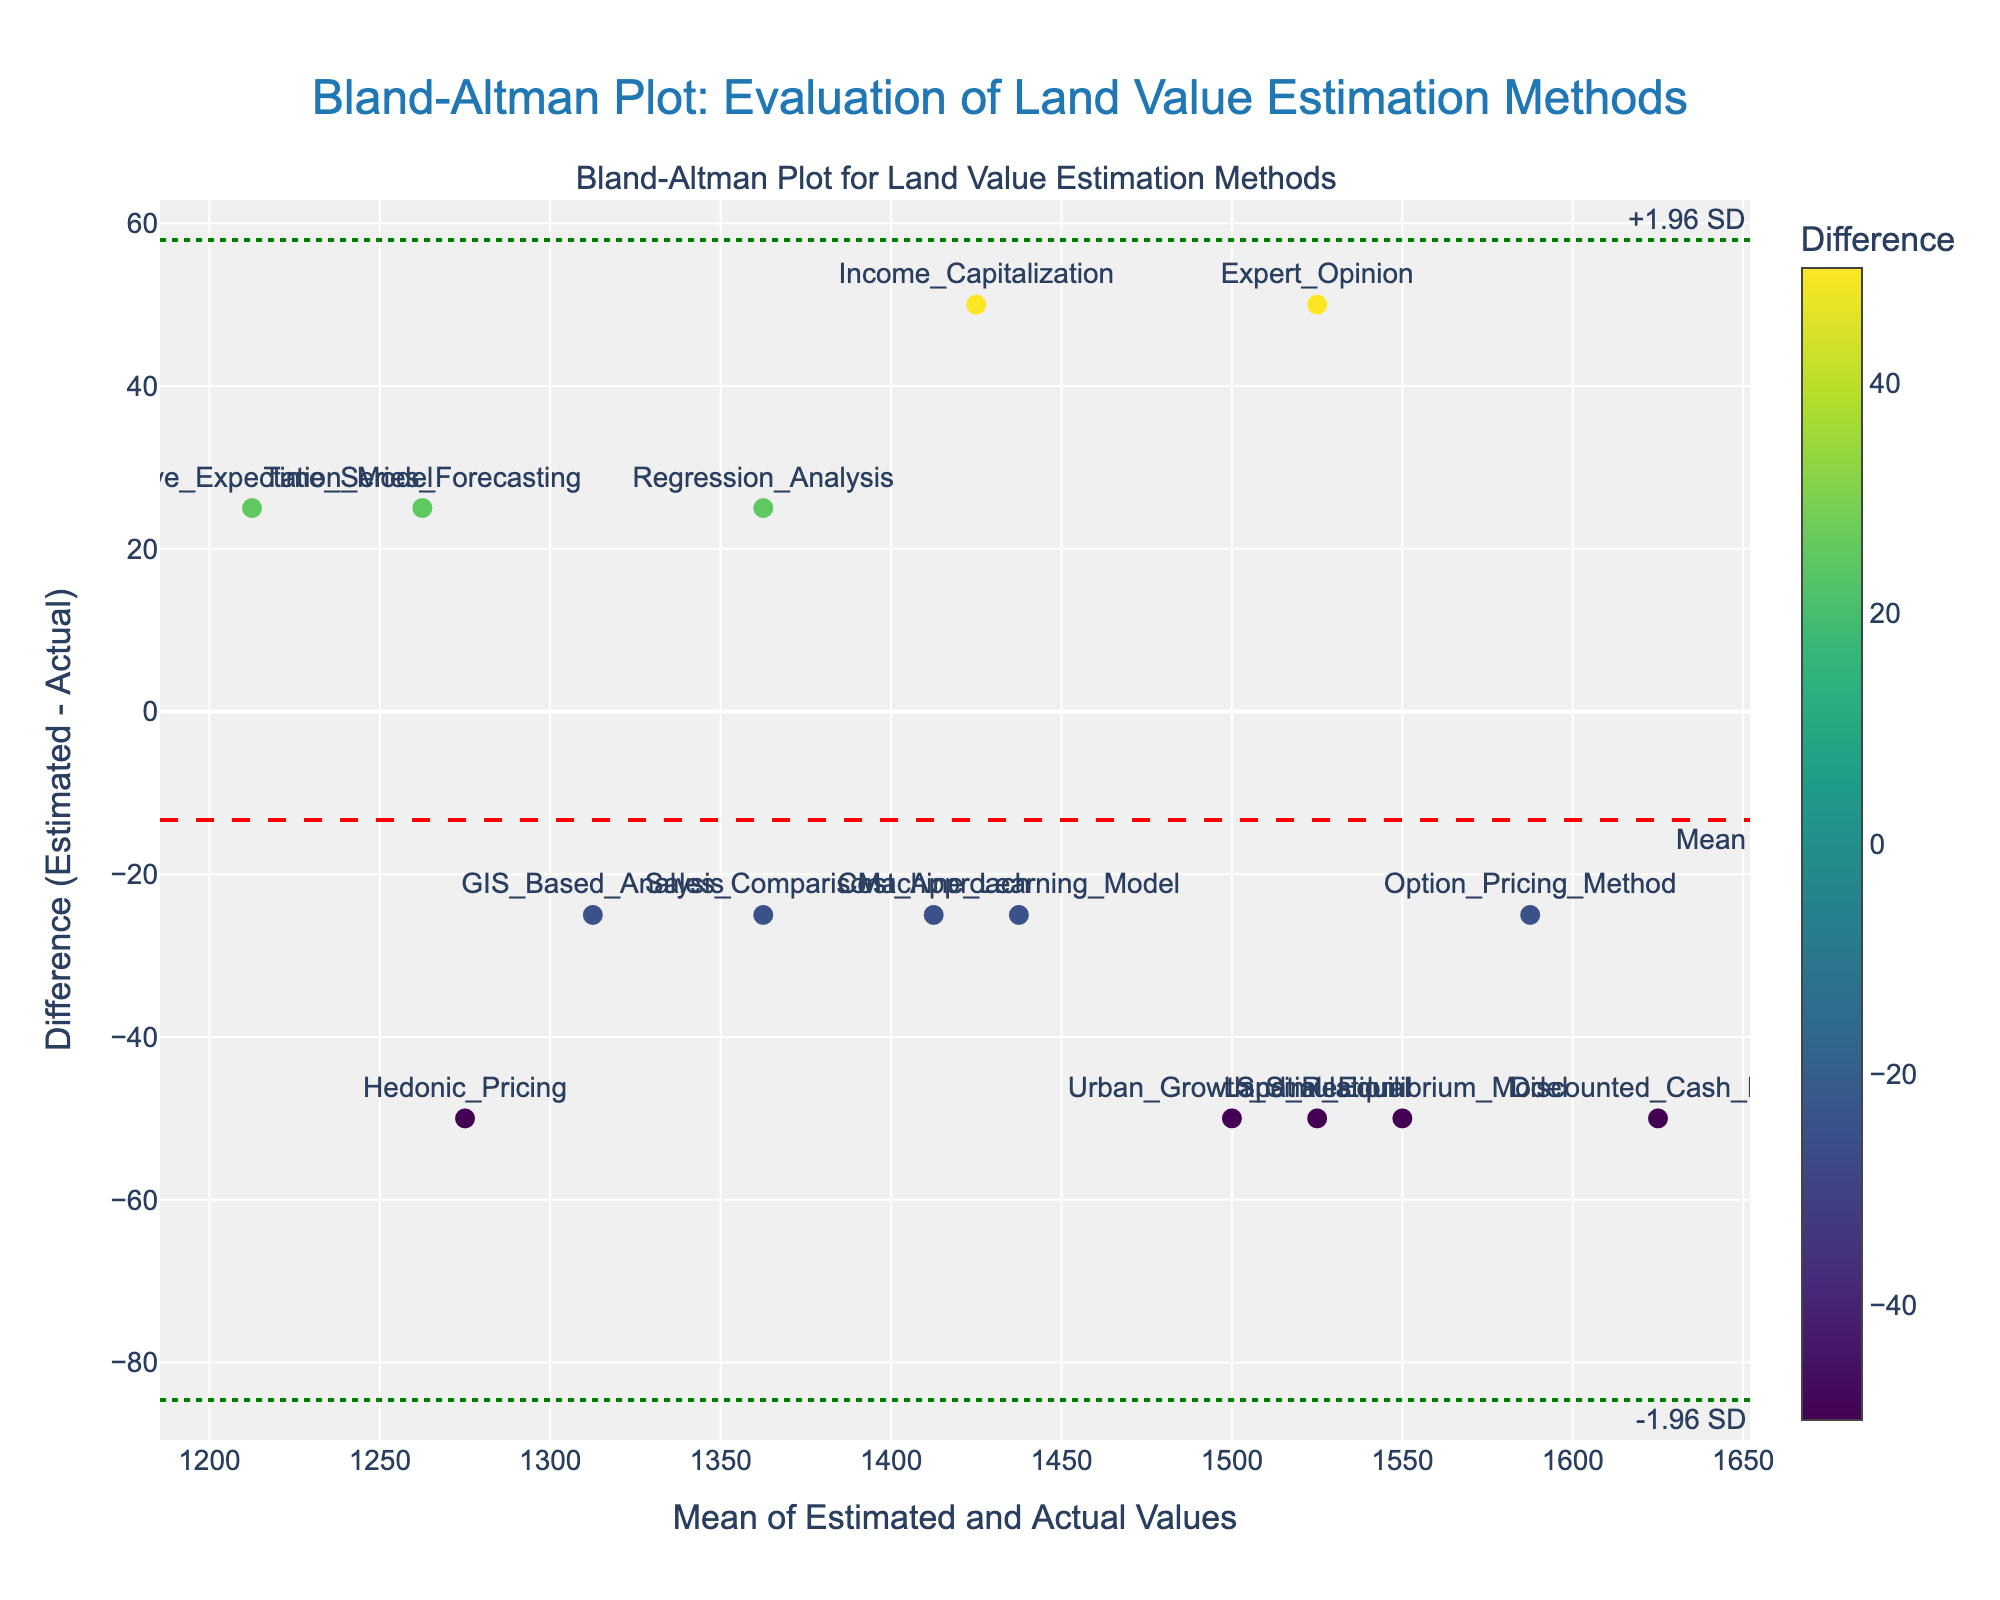What is the title of the Bland-Altman plot? The title is typically located at the top of the figure. It describes the content and purpose of the plot.
Answer: Bland-Altman Plot: Evaluation of Land Value Estimation Methods What is the y-axis title in the figure? The y-axis title describes what is being measured on the vertical axis of the plot.
Answer: Difference (Estimated - Actual) How many methods were evaluated in the Bland-Altman plot? Count the number of data points (markers) shown in the scatter plot. Each marker represents one method.
Answer: 15 Which methods have the largest positive and negative differences, respectively? Identify the methods with the highest and lowest points on the y-axis (difference). The largest positive difference is the highest y-value, and the largest negative difference is the lowest y-value.
Answer: Option Pricing Method (largest positive), Expert Opinion (largest negative) What is the mean difference between estimated and actual land values? The mean difference is represented by a horizontal line with a red dashed line labeled "Mean".
Answer: Approximately 16.67 What are the upper and lower limits of agreement? The upper and lower limits of agreement are determined by the green dotted lines labeled "+1.96 SD" and "-1.96 SD", respectively.
Answer: Upper: Approximately 59.10, Lower: Approximately -25.76 Which method has the closest estimation to the actual value? Identify the method with the difference closest to zero on the y-axis.
Answer: Time Series Forecasting How does the variability of the differences relate to the average of estimated and actual values? Assess whether differences increase or decrease as averages increase by observing the scatter plot pattern.
Answer: The variability doesn't show a clear pattern; it remains relatively stable across the range of averages Is there a consistent bias across the estimation methods for land value? Determine if the differences are consistently above or below zero which would indicate bias.
Answer: There is a slight positive bias (mean difference above zero) Are there any methods whose difference falls outside the limits of agreement? Check if any data points fall above the upper limit or below the lower limit.
Answer: No methods fall outside the limits of agreement 